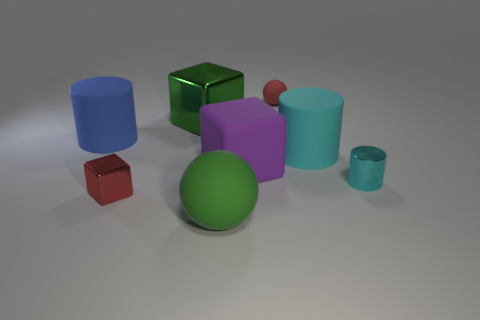How many other objects are the same color as the big rubber block?
Offer a terse response. 0. Are there any big things in front of the small red block?
Give a very brief answer. Yes. There is a purple thing; does it have the same shape as the small red thing that is to the left of the green sphere?
Keep it short and to the point. Yes. There is a tiny thing that is made of the same material as the big purple cube; what is its color?
Provide a short and direct response. Red. The small shiny cylinder has what color?
Offer a very short reply. Cyan. Is the large blue cylinder made of the same material as the green object behind the blue cylinder?
Your answer should be very brief. No. What number of things are both left of the big ball and in front of the tiny shiny cylinder?
Ensure brevity in your answer.  1. The purple matte object that is the same size as the blue rubber object is what shape?
Your answer should be very brief. Cube. There is a sphere in front of the tiny thing in front of the tiny cyan object; is there a sphere right of it?
Provide a short and direct response. Yes. Is the color of the large ball the same as the tiny metal object right of the green metallic cube?
Provide a succinct answer. No. 